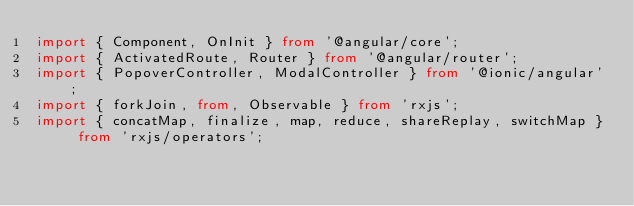<code> <loc_0><loc_0><loc_500><loc_500><_TypeScript_>import { Component, OnInit } from '@angular/core';
import { ActivatedRoute, Router } from '@angular/router';
import { PopoverController, ModalController } from '@ionic/angular';
import { forkJoin, from, Observable } from 'rxjs';
import { concatMap, finalize, map, reduce, shareReplay, switchMap } from 'rxjs/operators';</code> 